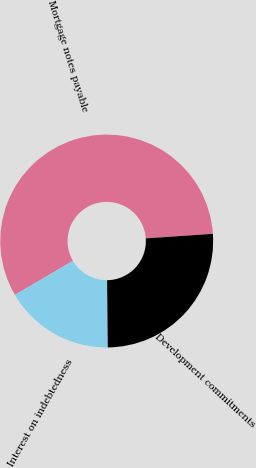<chart> <loc_0><loc_0><loc_500><loc_500><pie_chart><fcel>Mortgage notes payable<fcel>Interest on indebtedness<fcel>Development commitments<nl><fcel>57.36%<fcel>16.71%<fcel>25.92%<nl></chart> 